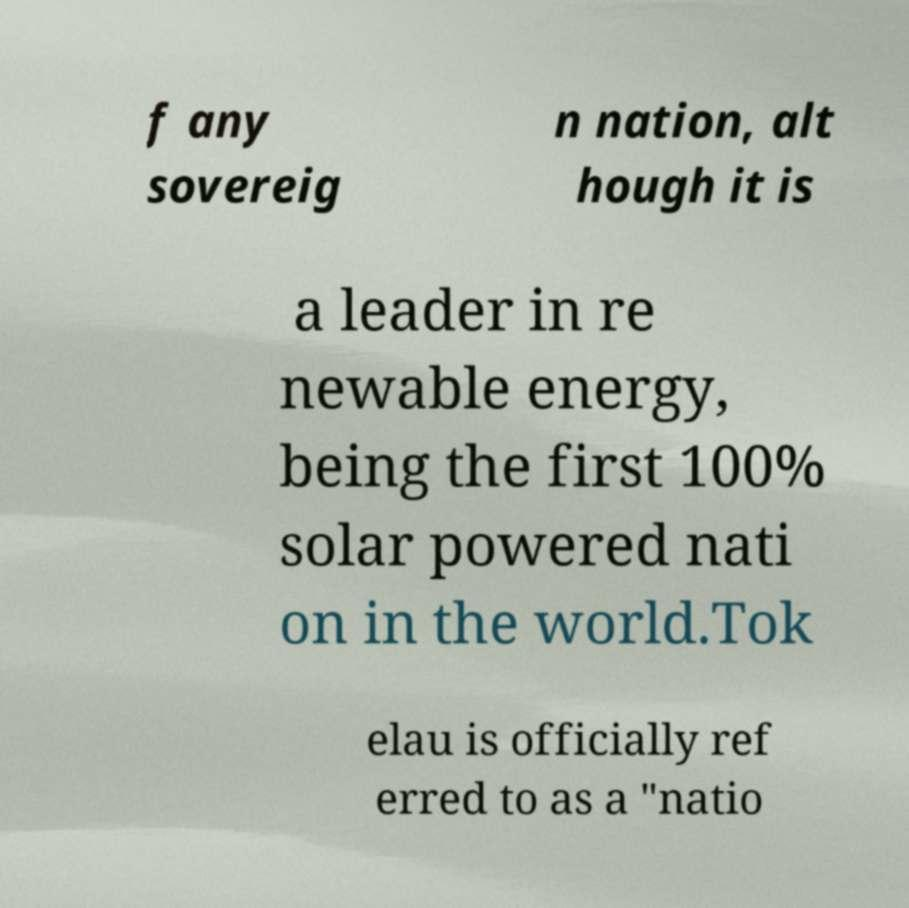Please read and relay the text visible in this image. What does it say? f any sovereig n nation, alt hough it is a leader in re newable energy, being the first 100% solar powered nati on in the world.Tok elau is officially ref erred to as a "natio 